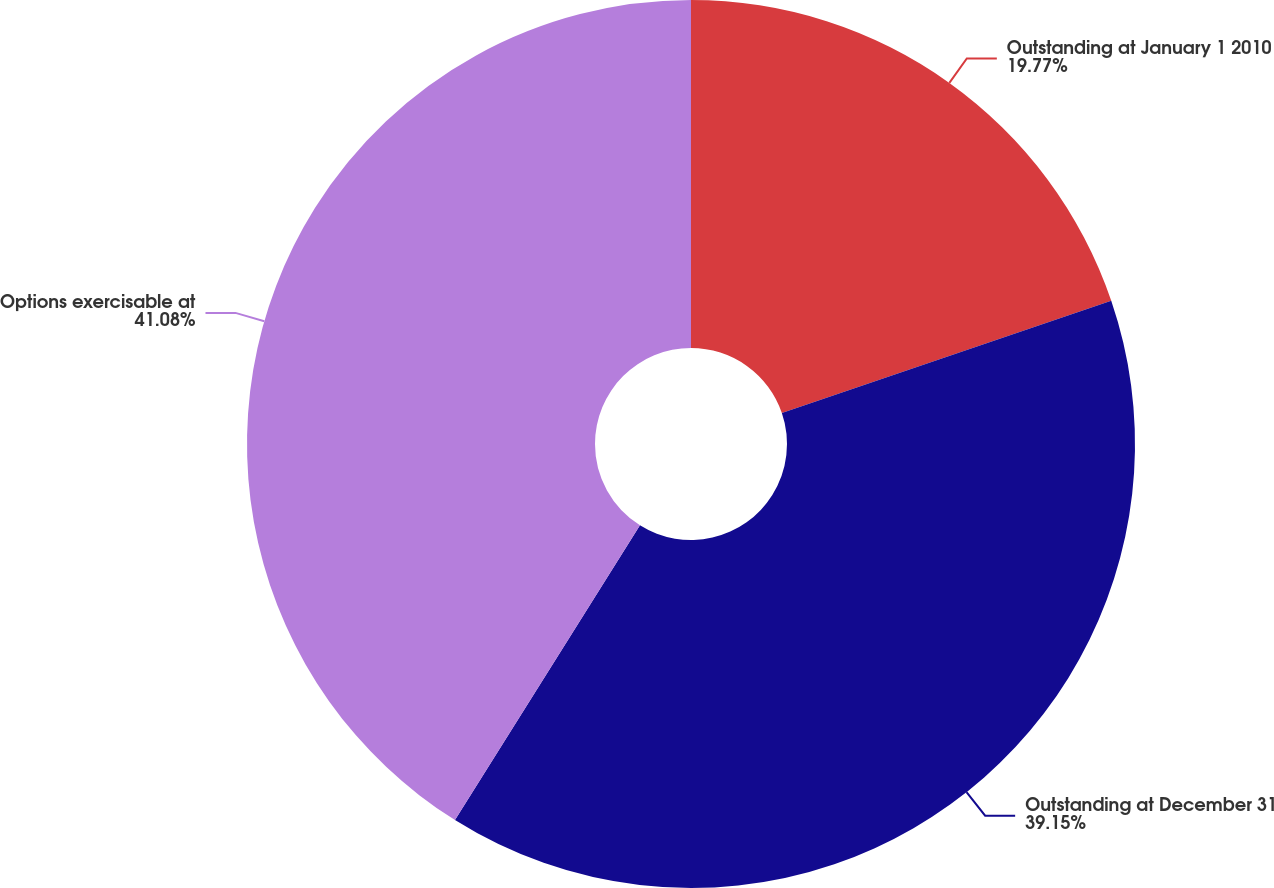Convert chart. <chart><loc_0><loc_0><loc_500><loc_500><pie_chart><fcel>Outstanding at January 1 2010<fcel>Outstanding at December 31<fcel>Options exercisable at<nl><fcel>19.77%<fcel>39.15%<fcel>41.08%<nl></chart> 